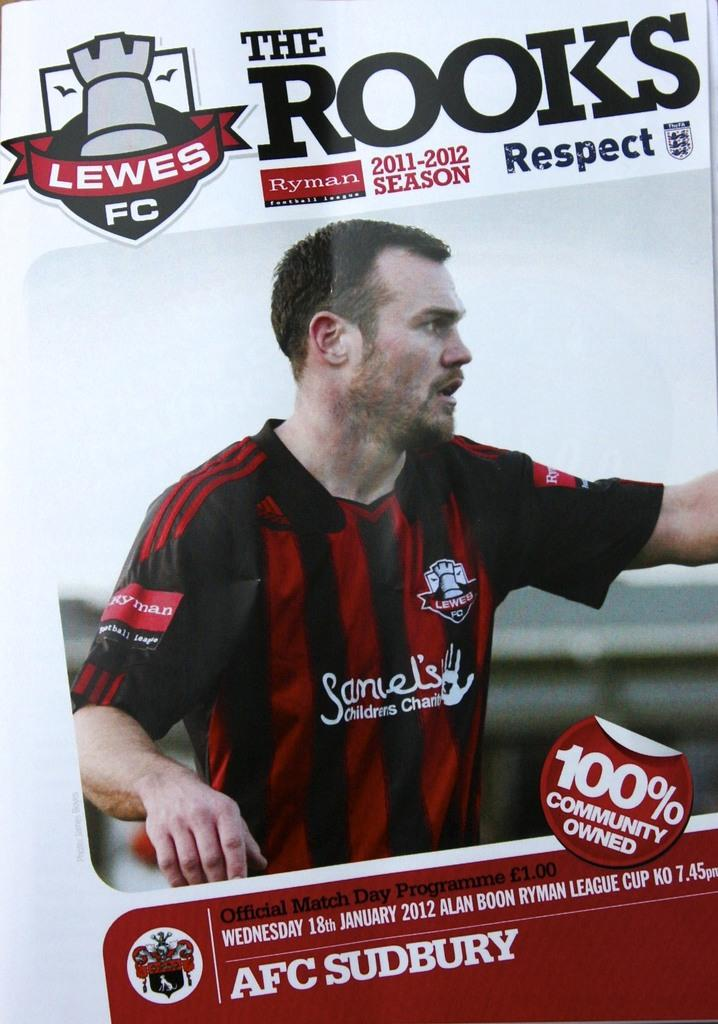<image>
Present a compact description of the photo's key features. a magazine that has the phrase the rooks on it 